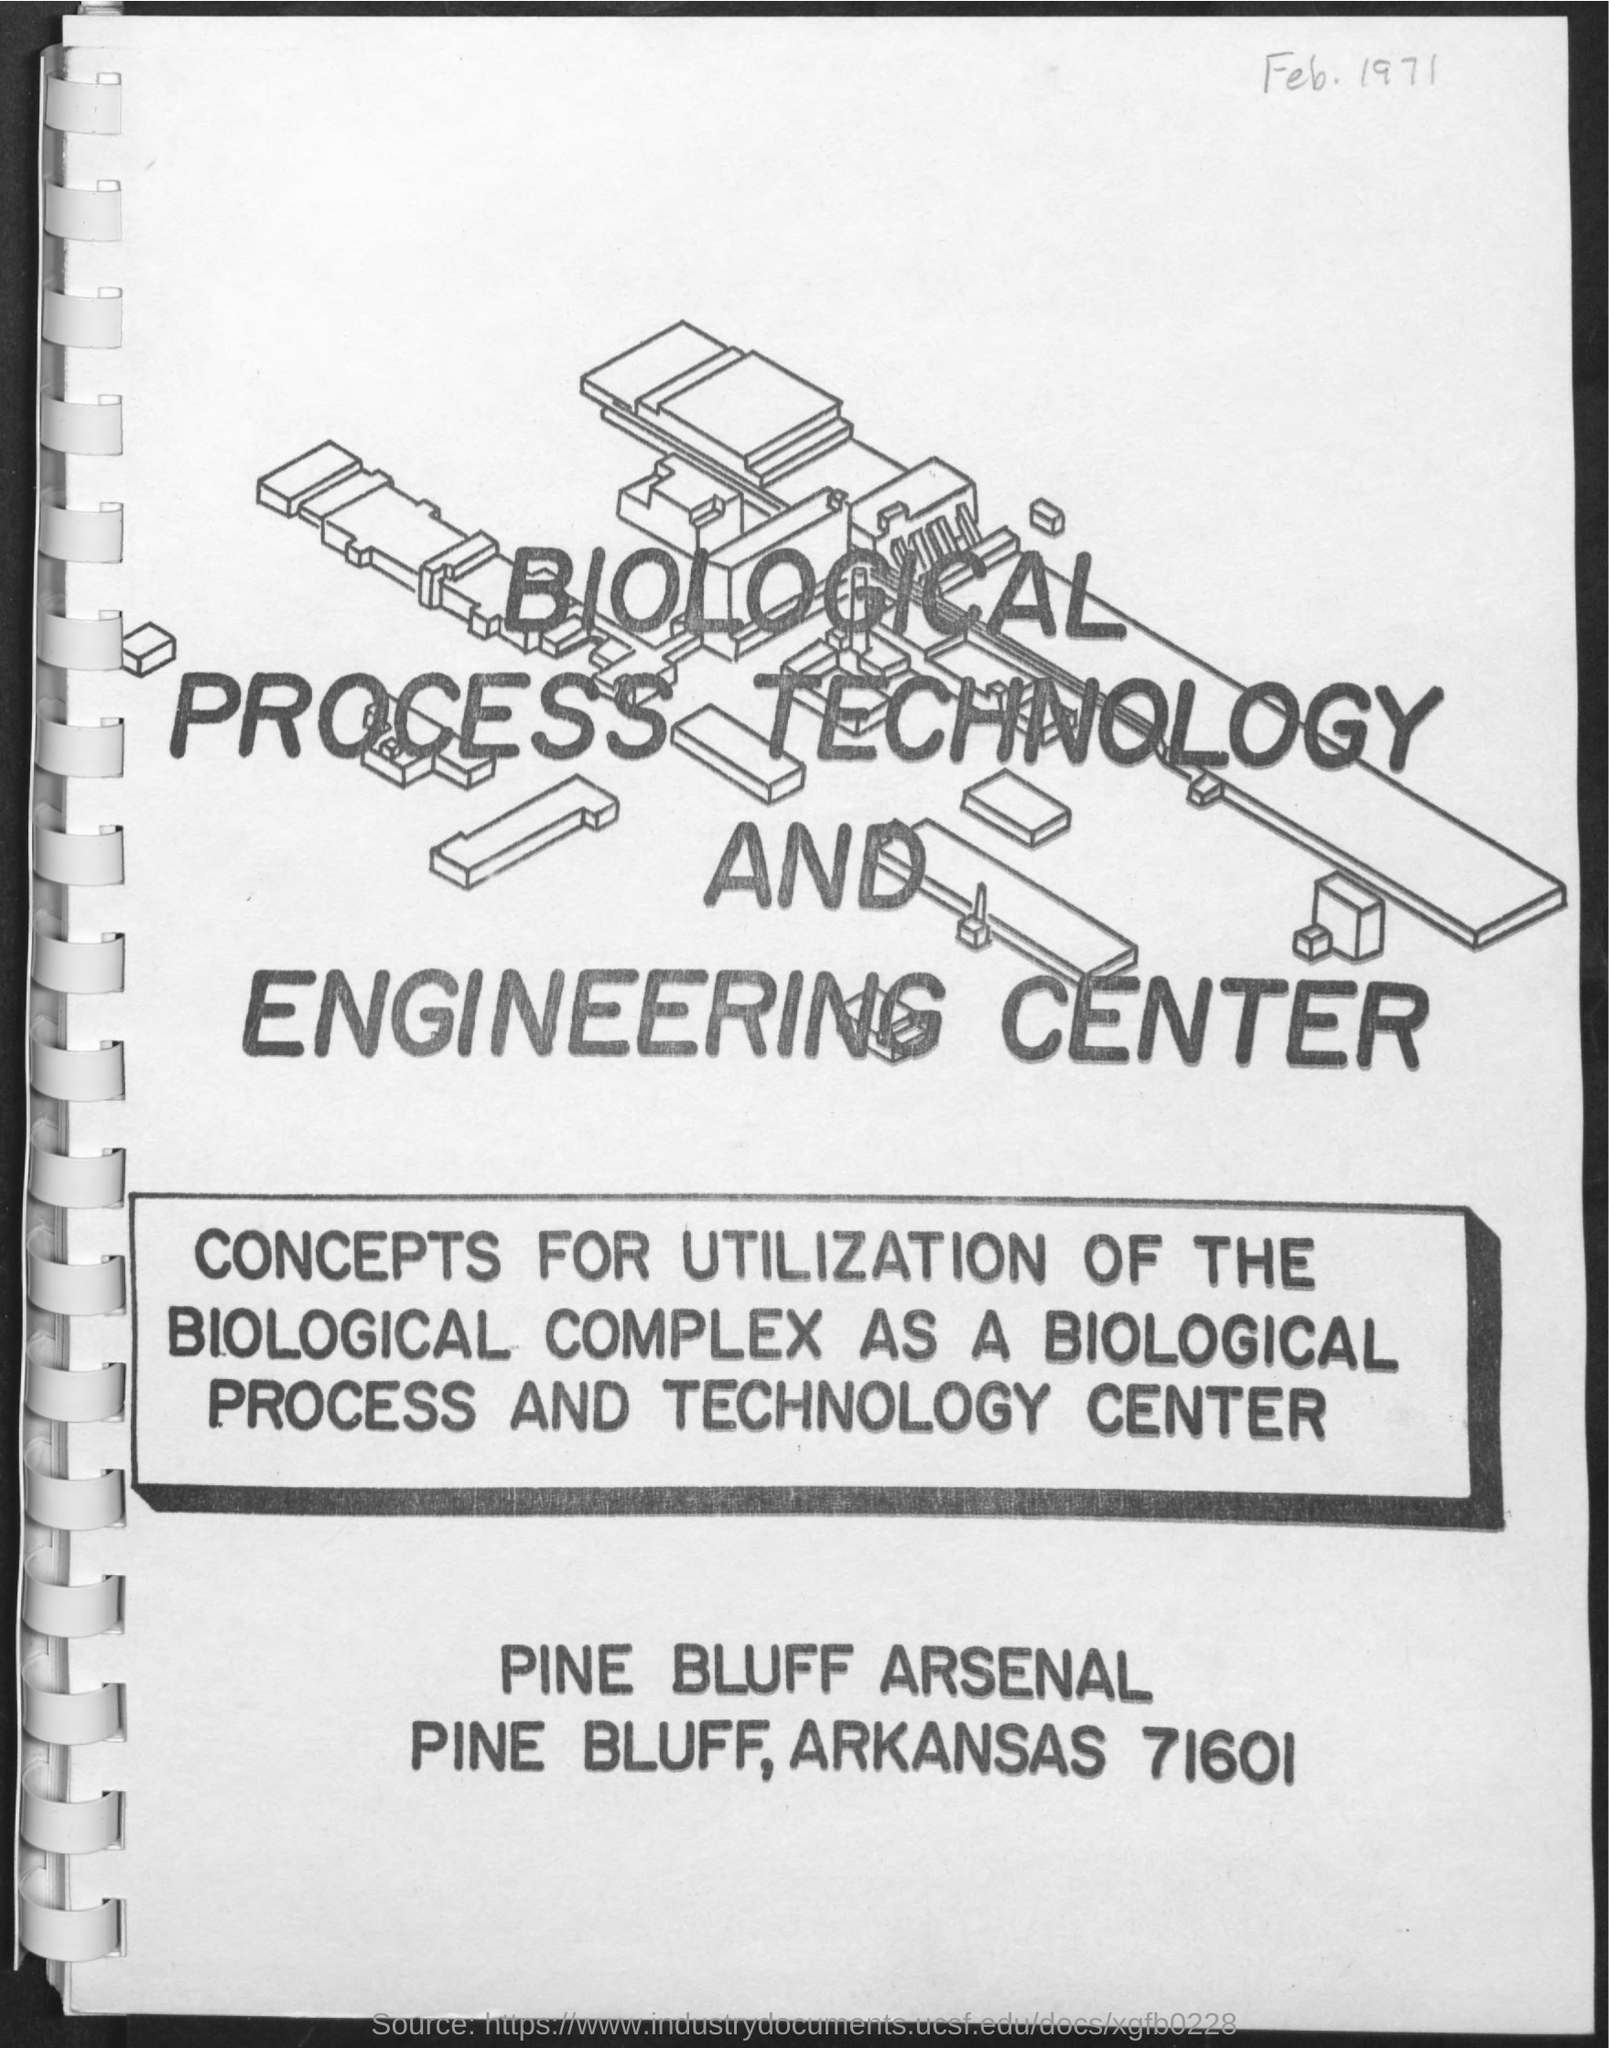What is the title of the document?
Offer a very short reply. Biological process technology and engineering center. What is the date mentioned in the document?
Give a very brief answer. Feb. 1971. 